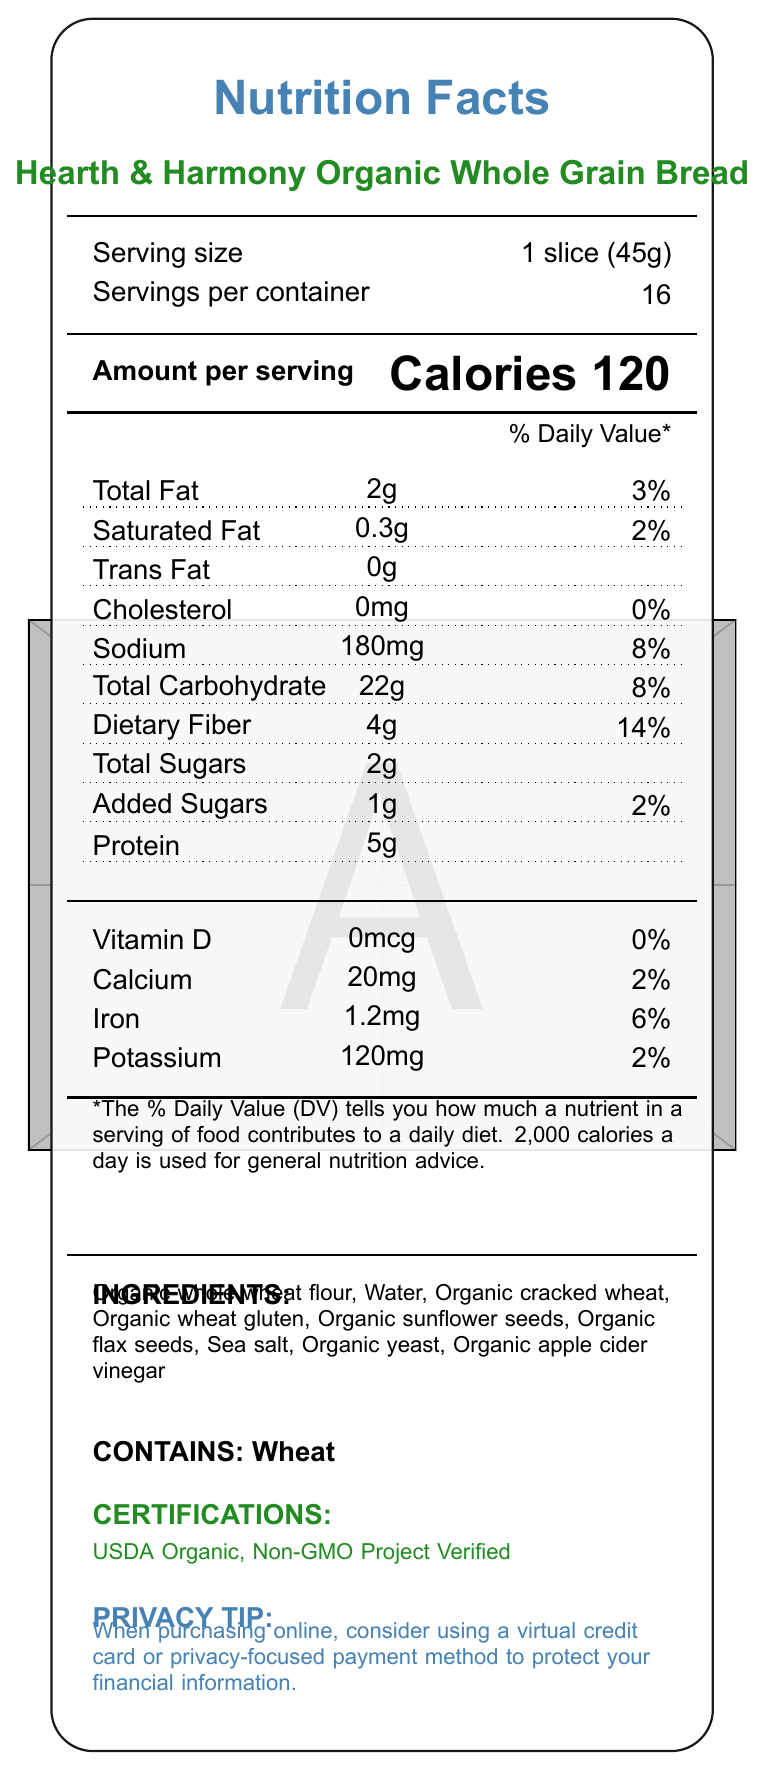What is the serving size of Hearth & Harmony Organic Whole Grain Bread? The serving size is specified as "1 slice (45g)" in the document.
Answer: 1 slice (45g) How many calories are there per serving? The document states that each serving (1 slice) contains 120 calories.
Answer: 120 What percentage of daily value for dietary fiber does a single serving provide? According to the document, dietary fiber content per serving is 4g, which is 14% of the daily value.
Answer: 14% List at least three main ingredients in this bread. The ingredients listed include: Organic whole wheat flour, Water, Organic cracked wheat, among others.
Answer: Organic whole wheat flour, Water, Organic cracked wheat How much protein is there per serving? The document states that each serving contains 5g of protein.
Answer: 5g What is the sodium content per serving? The document specifies that each serving contains 180mg of sodium.
Answer: 180mg Does the bread contain any added sugars? If yes, how much? The document specifies that there is 1g of added sugars per serving.
Answer: Yes, 1g Is this bread free from cholesterol? The document clearly states that the cholesterol content is 0mg per serving.
Answer: Yes Summarize the main nutritional points of the bread. The summary captures the key nutritional aspects, including fiber, protein, fat, and certification details mentioned in the document.
Answer: The Hearth & Harmony Organic Whole Grain Bread is a good source of fiber (4g per serving, 14% daily value) and contains 5g of protein per serving. It is low in saturated fat (0.3g) and has no cholesterol. The bread is certified USDA Organic and Non-GMO Project Verified and does not have any artificial preservatives or additives. How many calories would you consume if you ate two slices of this bread? The document provides the calories per one slice but doesn't directly give enough information to calculate the calories for two slices without making assumptions.
Answer: Cannot be determined 